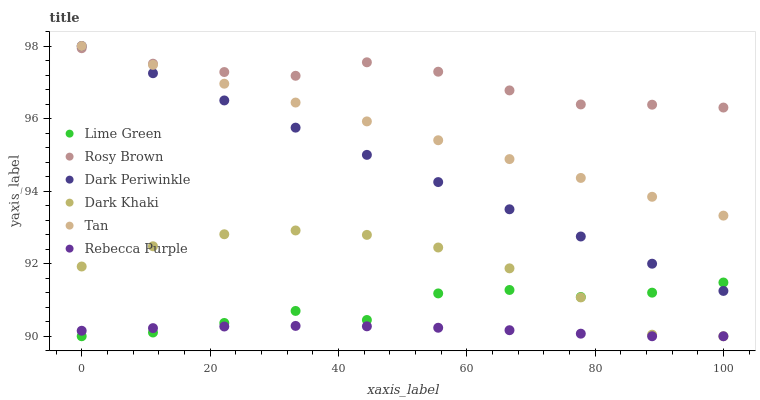Does Rebecca Purple have the minimum area under the curve?
Answer yes or no. Yes. Does Rosy Brown have the maximum area under the curve?
Answer yes or no. Yes. Does Dark Khaki have the minimum area under the curve?
Answer yes or no. No. Does Dark Khaki have the maximum area under the curve?
Answer yes or no. No. Is Tan the smoothest?
Answer yes or no. Yes. Is Lime Green the roughest?
Answer yes or no. Yes. Is Dark Khaki the smoothest?
Answer yes or no. No. Is Dark Khaki the roughest?
Answer yes or no. No. Does Dark Khaki have the lowest value?
Answer yes or no. Yes. Does Tan have the lowest value?
Answer yes or no. No. Does Dark Periwinkle have the highest value?
Answer yes or no. Yes. Does Dark Khaki have the highest value?
Answer yes or no. No. Is Lime Green less than Rosy Brown?
Answer yes or no. Yes. Is Rosy Brown greater than Dark Khaki?
Answer yes or no. Yes. Does Dark Khaki intersect Rebecca Purple?
Answer yes or no. Yes. Is Dark Khaki less than Rebecca Purple?
Answer yes or no. No. Is Dark Khaki greater than Rebecca Purple?
Answer yes or no. No. Does Lime Green intersect Rosy Brown?
Answer yes or no. No. 